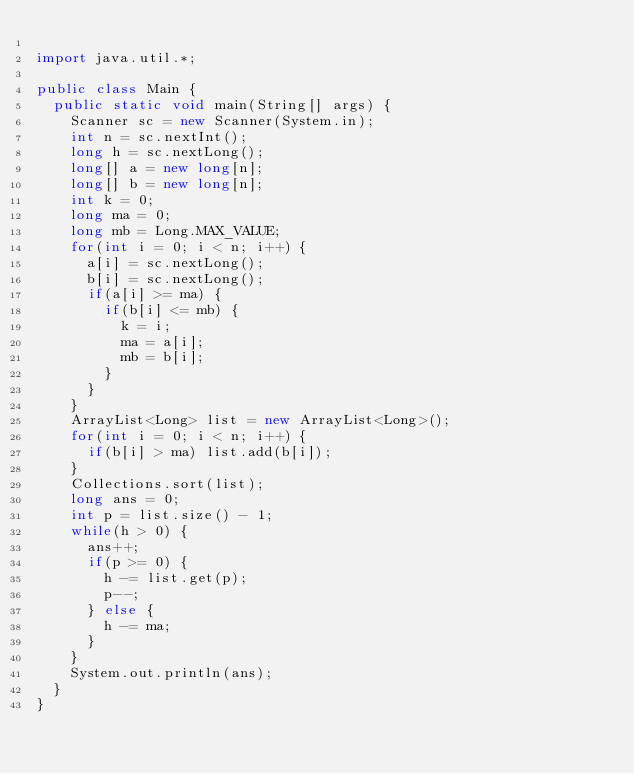<code> <loc_0><loc_0><loc_500><loc_500><_Java_>
import java.util.*;

public class Main {
  public static void main(String[] args) {
    Scanner sc = new Scanner(System.in);
    int n = sc.nextInt();
    long h = sc.nextLong();
    long[] a = new long[n];
    long[] b = new long[n];
    int k = 0;
    long ma = 0;
    long mb = Long.MAX_VALUE;
    for(int i = 0; i < n; i++) {
      a[i] = sc.nextLong();
      b[i] = sc.nextLong();
      if(a[i] >= ma) {
        if(b[i] <= mb) {
          k = i;
          ma = a[i];
          mb = b[i];
        }
      }
    }
    ArrayList<Long> list = new ArrayList<Long>();
    for(int i = 0; i < n; i++) {
      if(b[i] > ma) list.add(b[i]);
    }
    Collections.sort(list);
    long ans = 0;
    int p = list.size() - 1;
    while(h > 0) {
      ans++;
      if(p >= 0) {
        h -= list.get(p);
        p--;
      } else {
        h -= ma;
      }
    }
    System.out.println(ans);
  }
}</code> 